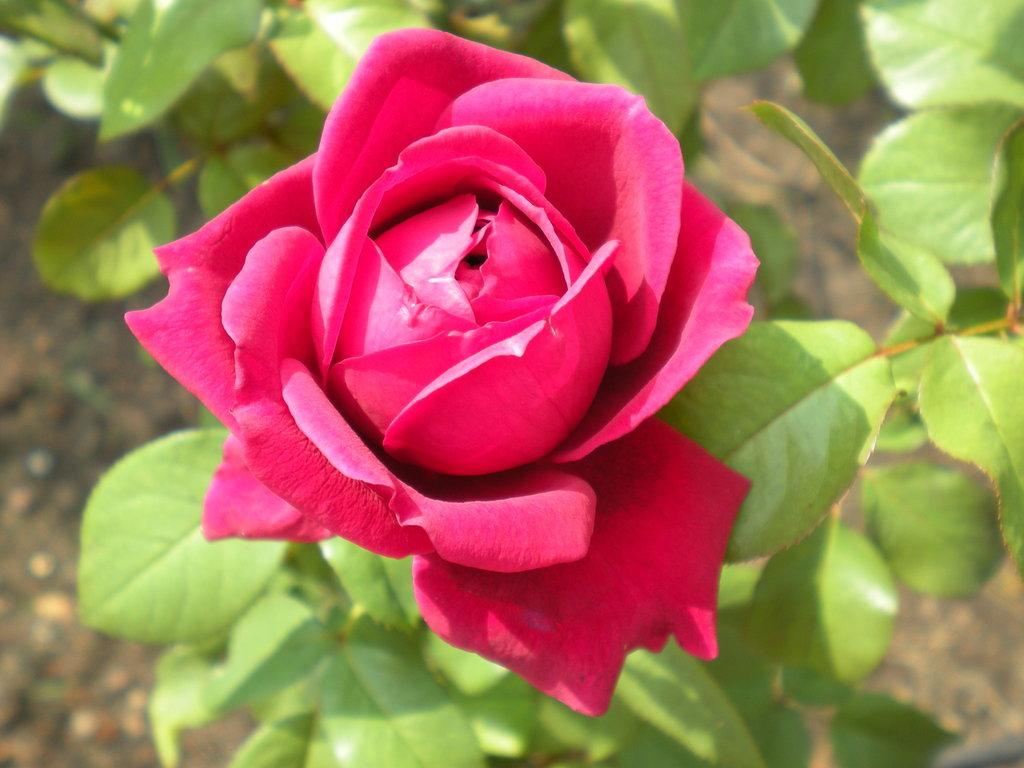What type of plant is visible in the image? There is a flower on a plant in the image. Can you describe the flower in more detail? Unfortunately, the image does not provide enough detail to describe the flower further. What is the plant's location in the image? The plant is not specified to be in a particular location within the image. How many brothers are playing soccer in the image? There are no brothers or soccer players present in the image; it only features a flower on a plant. 